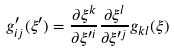<formula> <loc_0><loc_0><loc_500><loc_500>g ^ { \prime } _ { i j } ( \xi ^ { \prime } ) = \frac { \partial \xi ^ { k } } { \partial \xi ^ { \prime i } } \frac { \partial \xi ^ { l } } { \partial \xi ^ { \prime j } } g _ { k l } ( \xi )</formula> 